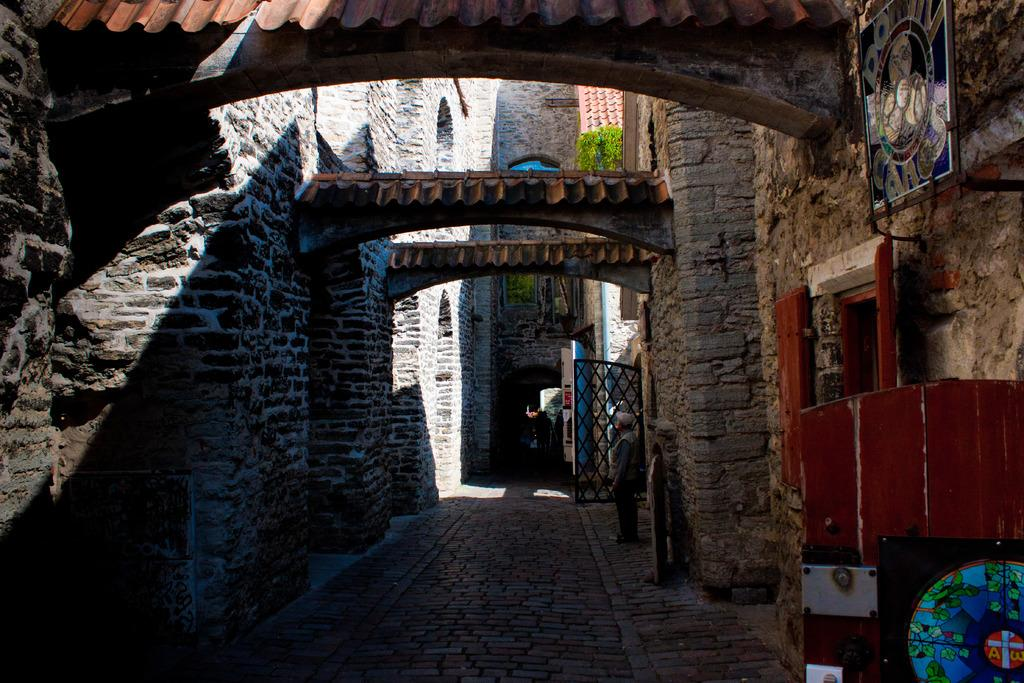What type of structures can be seen in the image? There are buildings in the image. What is a feature of the buildings in the image? There is a wall in the image. What can be seen on the wall in the image? There is a board attached to the wall in the image. What is a common feature of buildings that can be seen in the image? There are windows in the image. What is another element present in the image? There are objects in the image. What is a possible entrance in the image? There is a gate in the image. Can you tell me where the sofa is located in the image? There is no sofa present in the image. What type of game is being played on the board in the image? There is no game being played on the board in the image. 